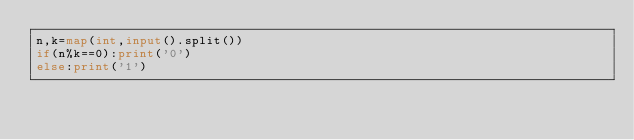Convert code to text. <code><loc_0><loc_0><loc_500><loc_500><_Python_>n,k=map(int,input().split())
if(n%k==0):print('0')
else:print('1')</code> 